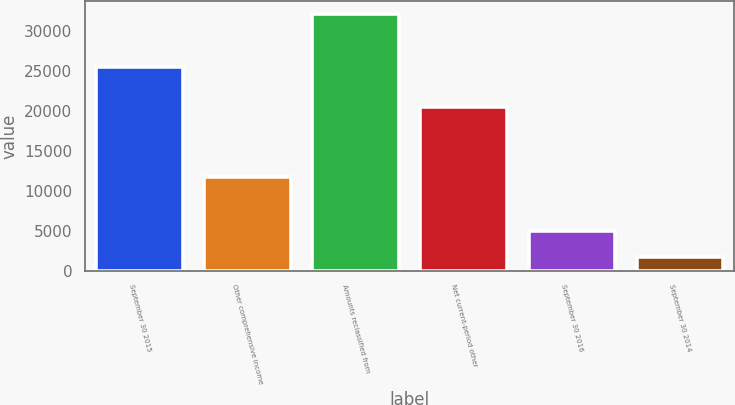<chart> <loc_0><loc_0><loc_500><loc_500><bar_chart><fcel>September 30 2015<fcel>Other comprehensive income<fcel>Amounts reclassified from<fcel>Net current-period other<fcel>September 30 2016<fcel>September 30 2014<nl><fcel>25437<fcel>11662<fcel>32117<fcel>20455<fcel>4982<fcel>1674<nl></chart> 